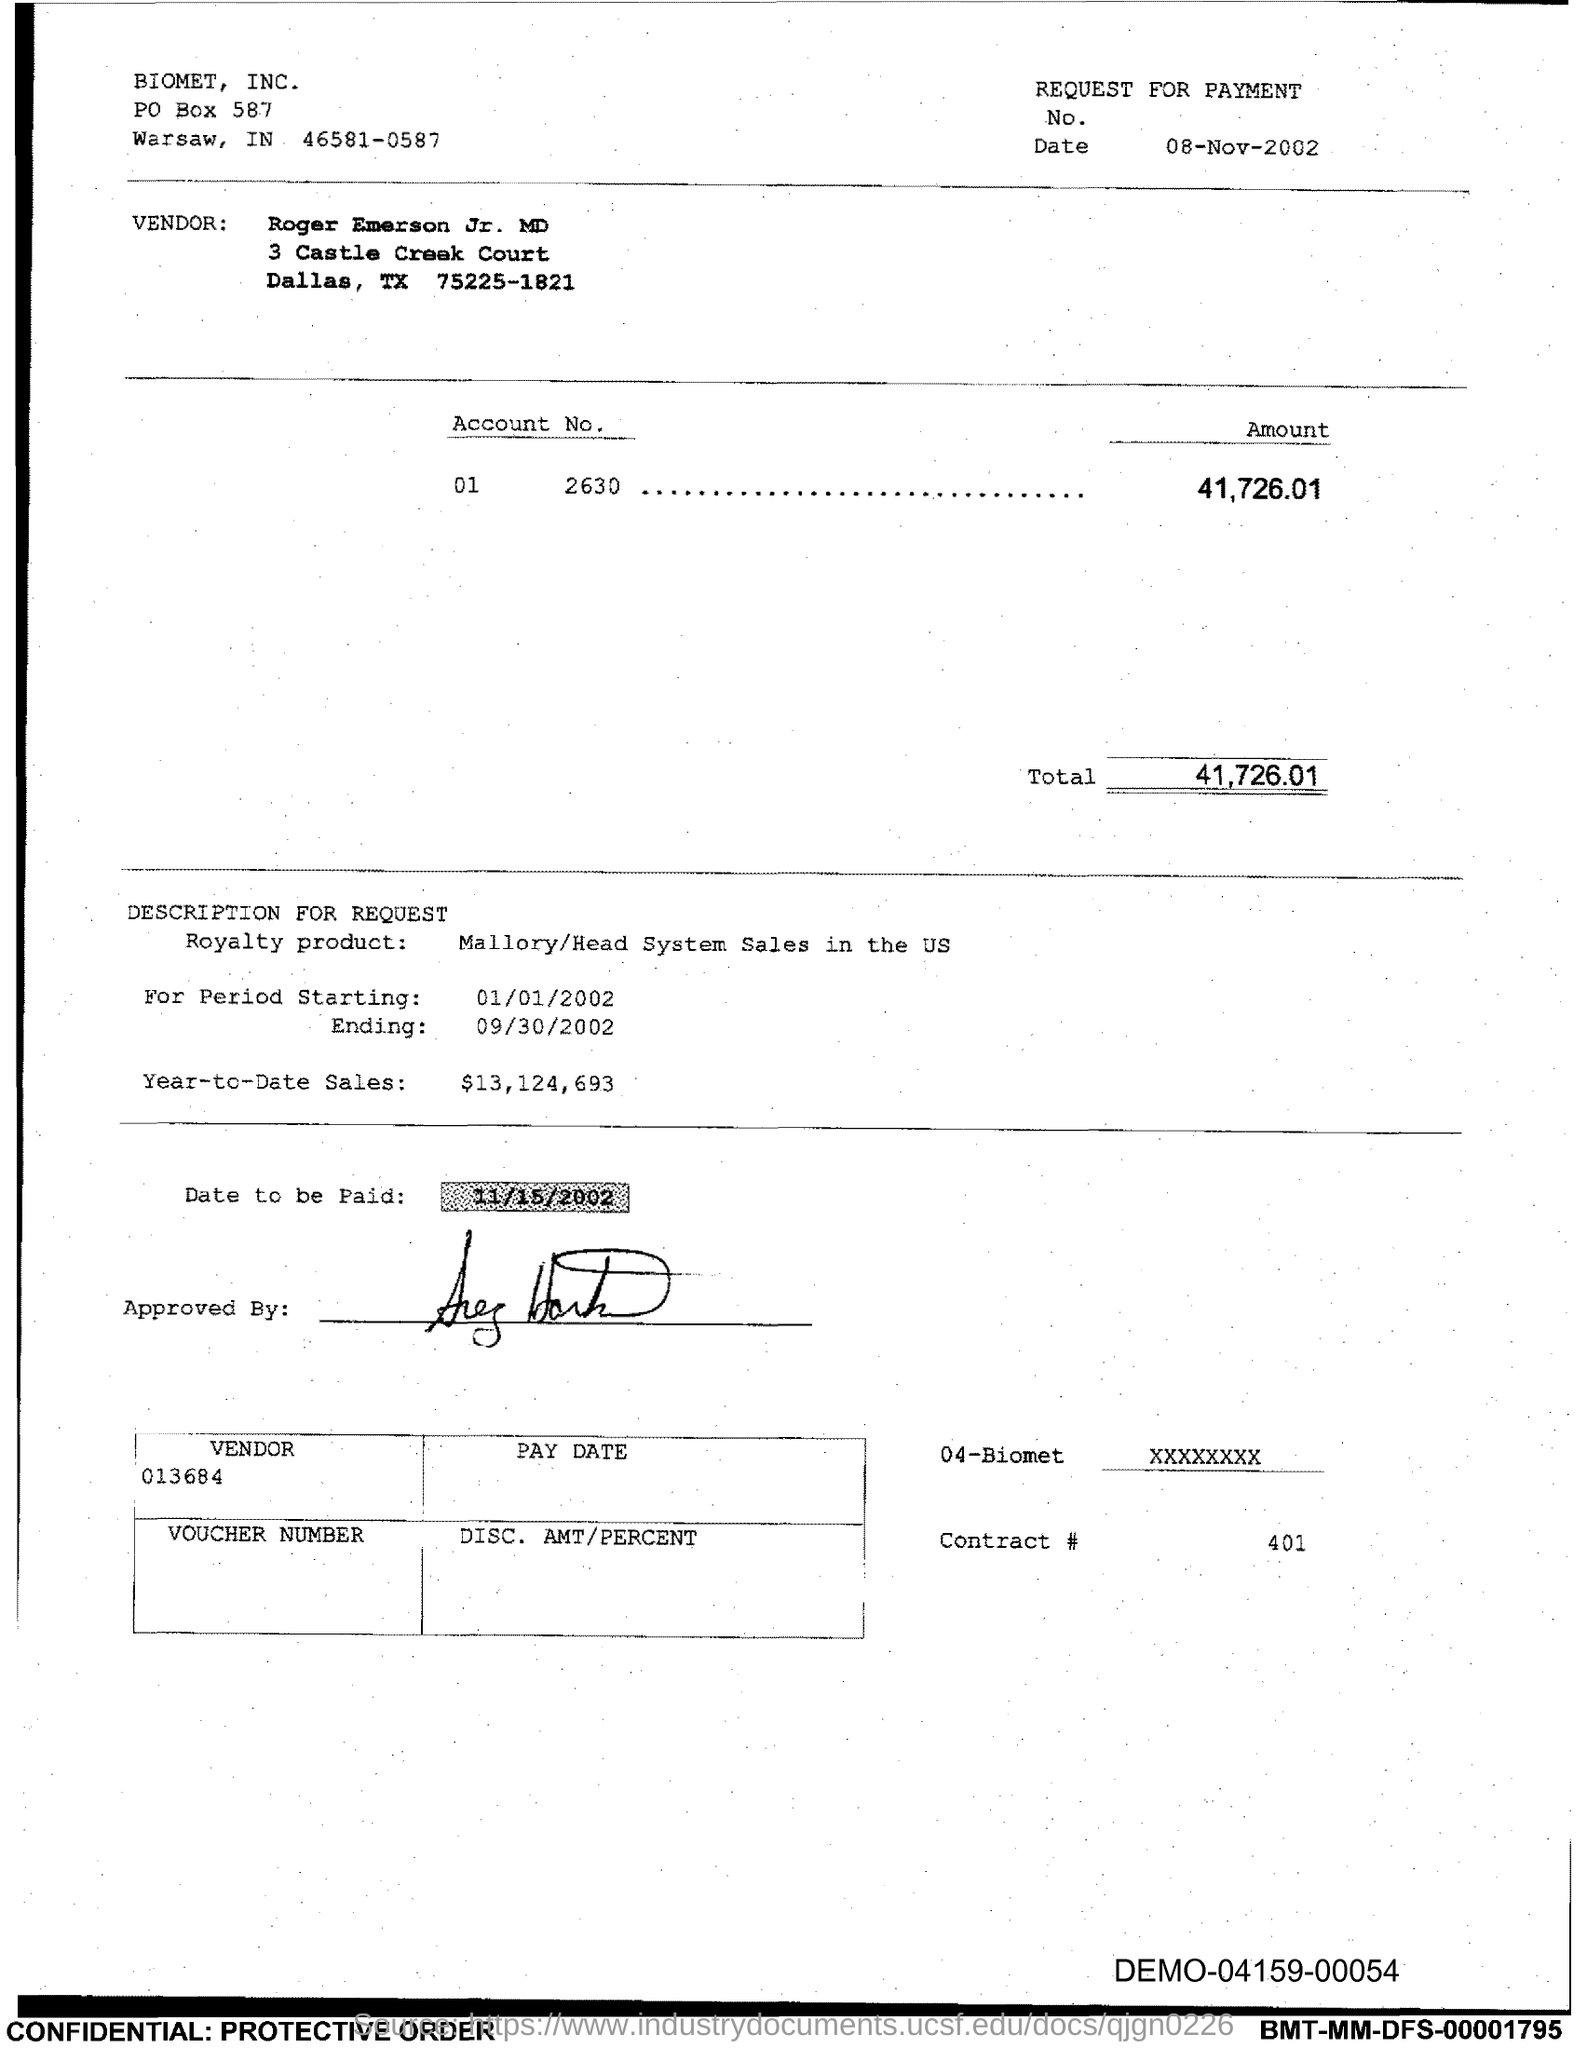What is the po box no. of biomet, inc. ?
Your answer should be compact. 587. What is the date to be paid?
Give a very brief answer. 11/15/2002. What is the total ?
Your answer should be compact. 41,726.01. What is the contract# ?
Make the answer very short. 401. In which city is biomet, inc ?
Your answer should be very brief. Warsaw. 